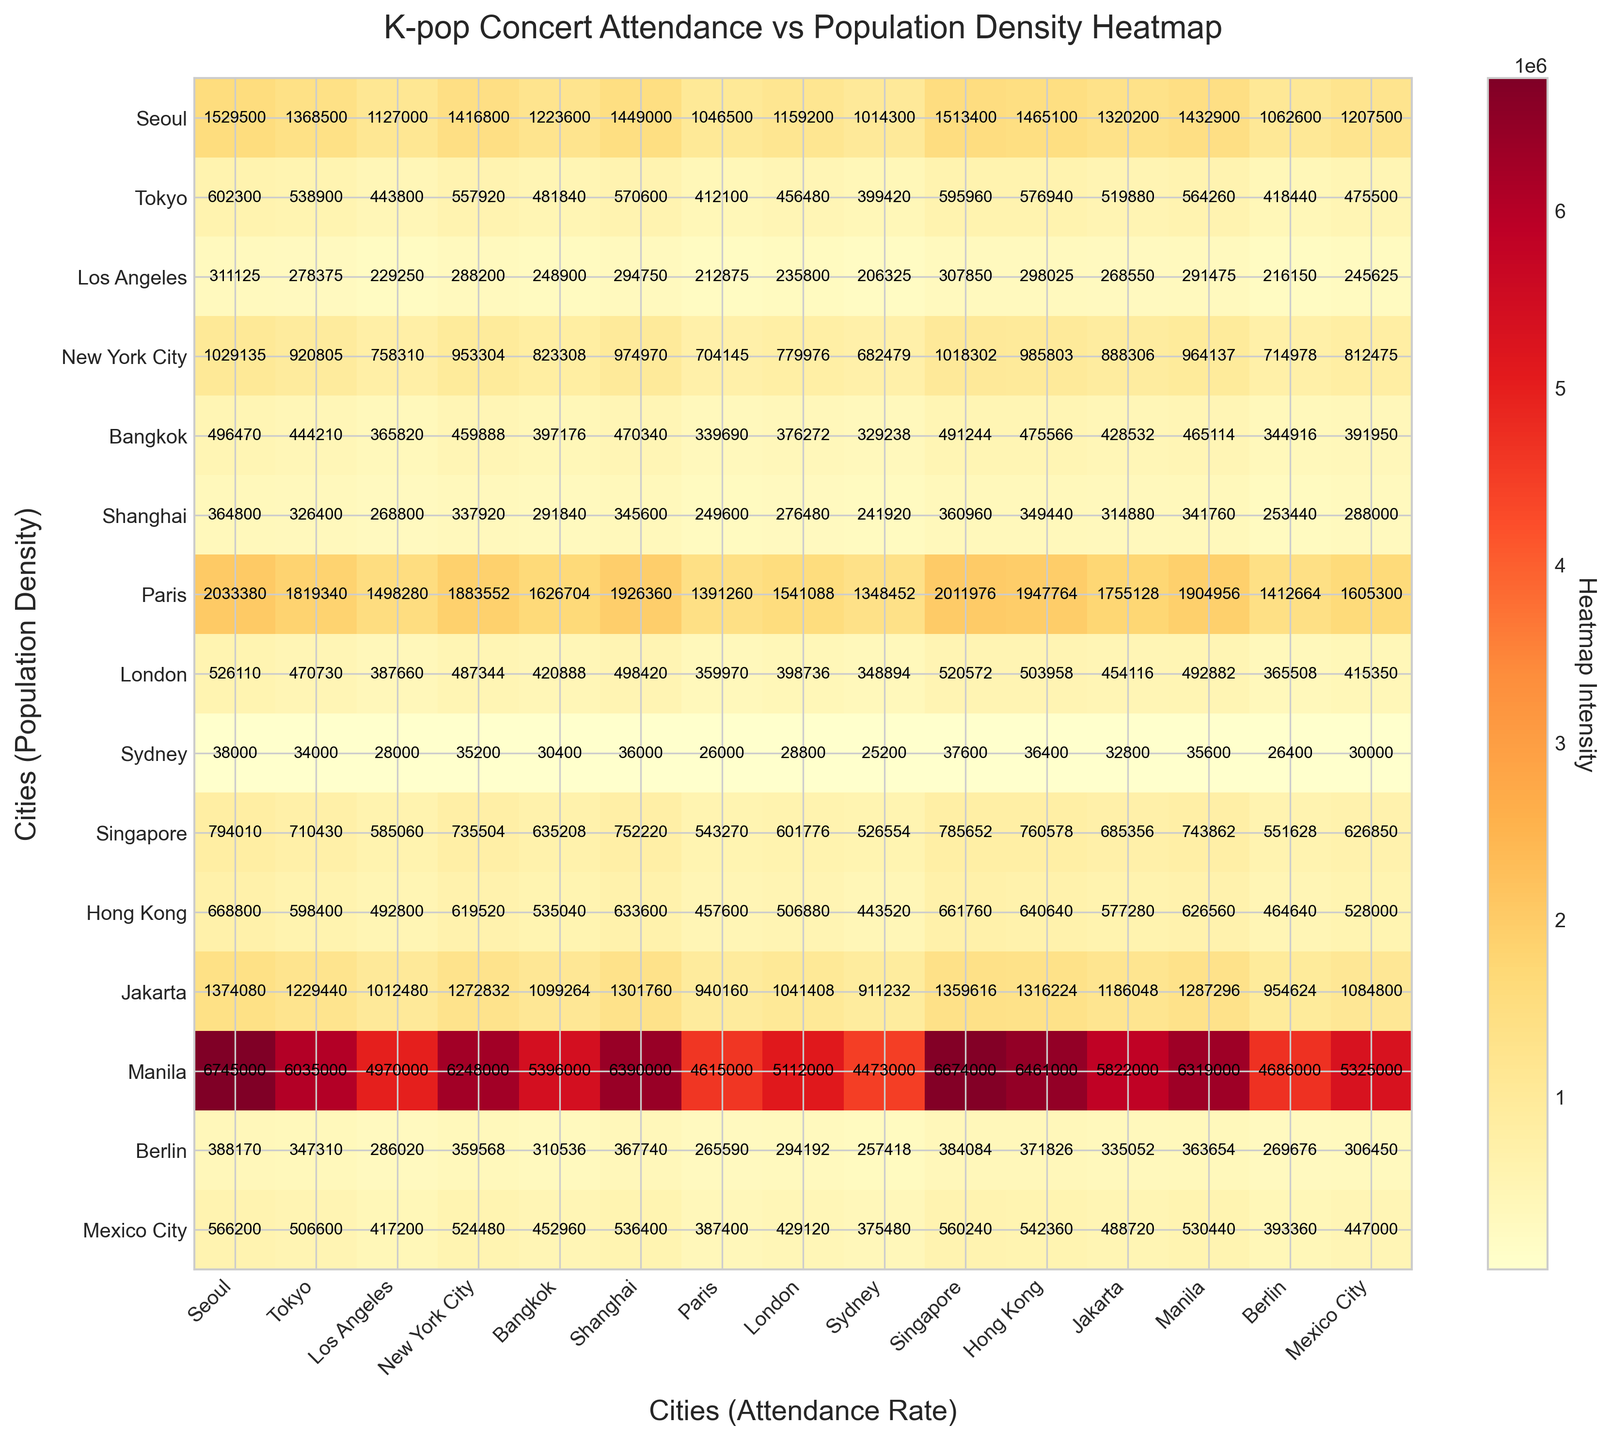What's the title of the heatmap? The title is usually located at the top of the figure.
Answer: K-pop Concert Attendance vs Population Density Heatmap How many cities are represented on the heatmap? Count the number of city labels on either x-axis or y-axis.
Answer: 15 Which city has the highest concert attendance rate? Look at the column labels on the x-axis and identify the city with the highest percentage.
Answer: Seoul Which city has the lowest population density? Look at the row labels on the y-axis and identify the city with the lowest number per sq km.
Answer: Sydney What's the heatmap intensity value for Tokyo vs. Seoul? Locate the intersection of Tokyo's column and Seoul's row to read the intensity value.
Answer: 1493500 How does the concert attendance rate of New York City compare to Los Angeles? On the x-axis, compare the percentage figures for New York City and Los Angeles.
Answer: New York City has a higher attendance rate What's the average heatmap intensity value across all city pairs? Sum all heatmap intensity values and divide by the number of city pairs, which is 15x15 = 225.
Answer: Varying values, calculated using visual intensity data Which cities have a heatmap intensity of over a million units when compared together? Identify city pairs from the heatmap where the intensity value exceeds 1000000.
Answer: Examples include Seoul vs. many cities like Tokyo and Jakarta Does a higher population density seem to correspond to higher concert attendance? Compare cities with high population densities to their attendance rates.
Answer: Generally, yes, e.g., Seoul, Singapore, Hong Kong What can be inferred about the concert attendance in Sydney with its low population density? Analyze the heatmap intensity values for Sydney compared to other highly attended cities.
Answer: Sydney tends to have low attendance rates in comparison 